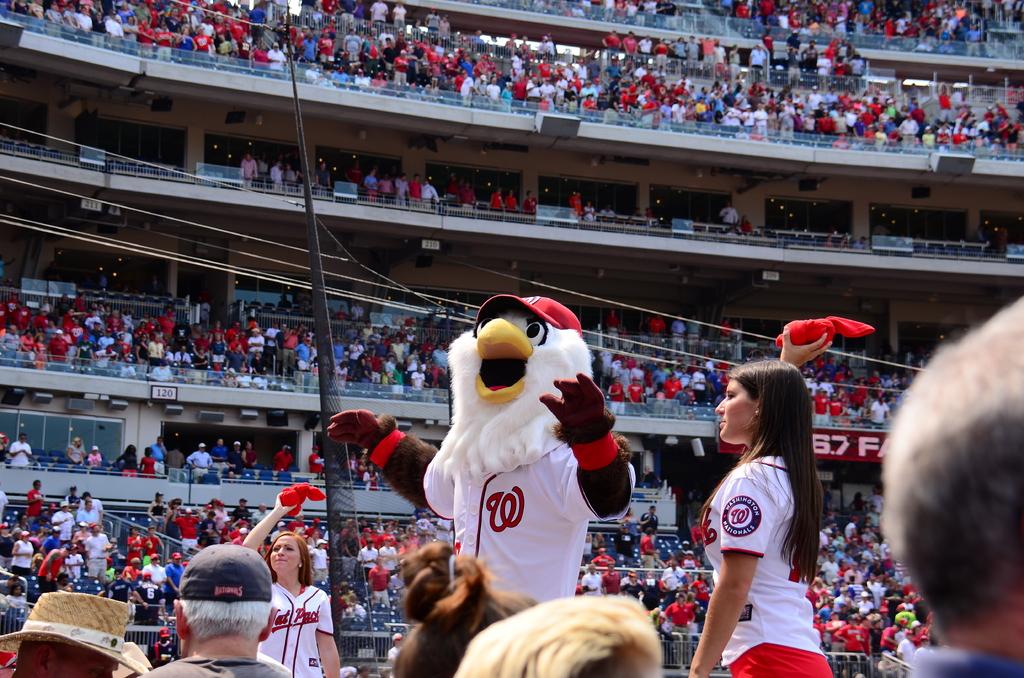What letter does this team's symbol look like?
Ensure brevity in your answer.  W. What numbers can you see on the stands behind the woman?
Give a very brief answer. 67. 